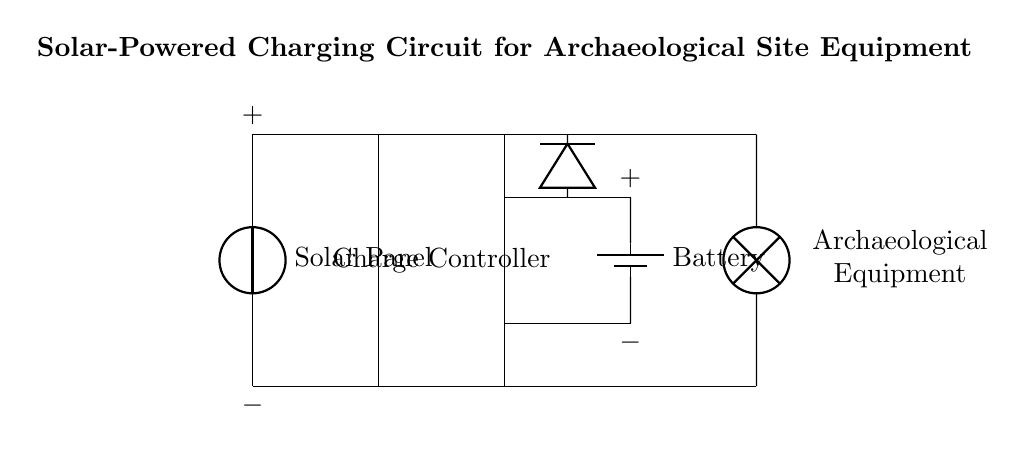What is the function of the solar panel in this circuit? The solar panel converts sunlight into electrical energy, providing the initial power source for the charging circuit.
Answer: Converts sunlight What type of battery is shown in the circuit? The circuit diagram includes a rechargeable battery, as it is designed to store energy from the solar panel.
Answer: Rechargeable battery Which component protects against reverse current? The diode in the circuit is responsible for preventing reverse current from flowing back into the solar panel or battery when there is no sun or during battery discharge.
Answer: Diode How many main components are there in the circuit? The circuit consists of four main components: solar panel, charge controller, battery, and load.
Answer: Four What does the load represent in this circuit? The load represents the archaeological equipment that will utilize the power supplied by the battery for its operation.
Answer: Archaeological equipment Why is a charge controller included in this circuit? The charge controller regulates the voltage and current coming from the solar panel to the battery, preventing overcharging and ensuring safe operation.
Answer: Regulates voltage 